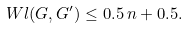<formula> <loc_0><loc_0><loc_500><loc_500>\ W l ( G , G ^ { \prime } ) \leq 0 . 5 \, n + 0 . 5 .</formula> 